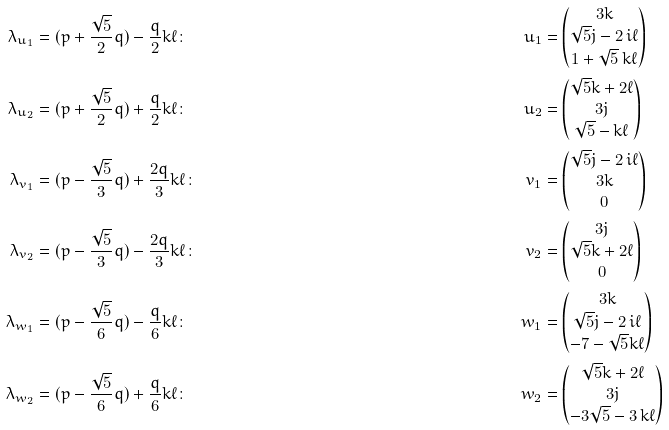<formula> <loc_0><loc_0><loc_500><loc_500>\lambda _ { u _ { 1 } } & = ( p + \frac { \sqrt { 5 } } { 2 } q ) - \frac { q } { 2 } k \ell \colon & u _ { 1 } & = \begin{pmatrix} 3 k \\ \sqrt { 5 } j - 2 \, i \ell \\ 1 + \sqrt { 5 } \, k \ell \end{pmatrix} \\ \lambda _ { u _ { 2 } } & = ( p + \frac { \sqrt { 5 } } { 2 } q ) + \frac { q } { 2 } k \ell \colon & u _ { 2 } & = \begin{pmatrix} \sqrt { 5 } k + 2 \ell \\ 3 j \\ \sqrt { 5 } - k \ell \end{pmatrix} \\ \lambda _ { v _ { 1 } } & = ( p - \frac { \sqrt { 5 } } { 3 } q ) + \frac { 2 q } { 3 } k \ell \colon & v _ { 1 } & = \begin{pmatrix} \sqrt { 5 } j - 2 \, i \ell \\ 3 k \\ 0 \end{pmatrix} \\ \lambda _ { v _ { 2 } } & = ( p - \frac { \sqrt { 5 } } { 3 } q ) - \frac { 2 q } { 3 } k \ell \colon & v _ { 2 } & = \begin{pmatrix} 3 j \\ \sqrt { 5 } k + 2 \ell \\ 0 \end{pmatrix} \\ \lambda _ { w _ { 1 } } & = ( p - \frac { \sqrt { 5 } } { 6 } q ) - \frac { q } { 6 } k \ell \colon & w _ { 1 } & = \begin{pmatrix} 3 k \\ \sqrt { 5 } j - 2 \, i \ell \\ - 7 - \sqrt { 5 } k \ell \end{pmatrix} \\ \lambda _ { w _ { 2 } } & = ( p - \frac { \sqrt { 5 } } { 6 } q ) + \frac { q } { 6 } k \ell \colon & w _ { 2 } & = \begin{pmatrix} \sqrt { 5 } k + 2 \ell \\ 3 j \\ - 3 \sqrt { 5 } - 3 \, k \ell \end{pmatrix}</formula> 